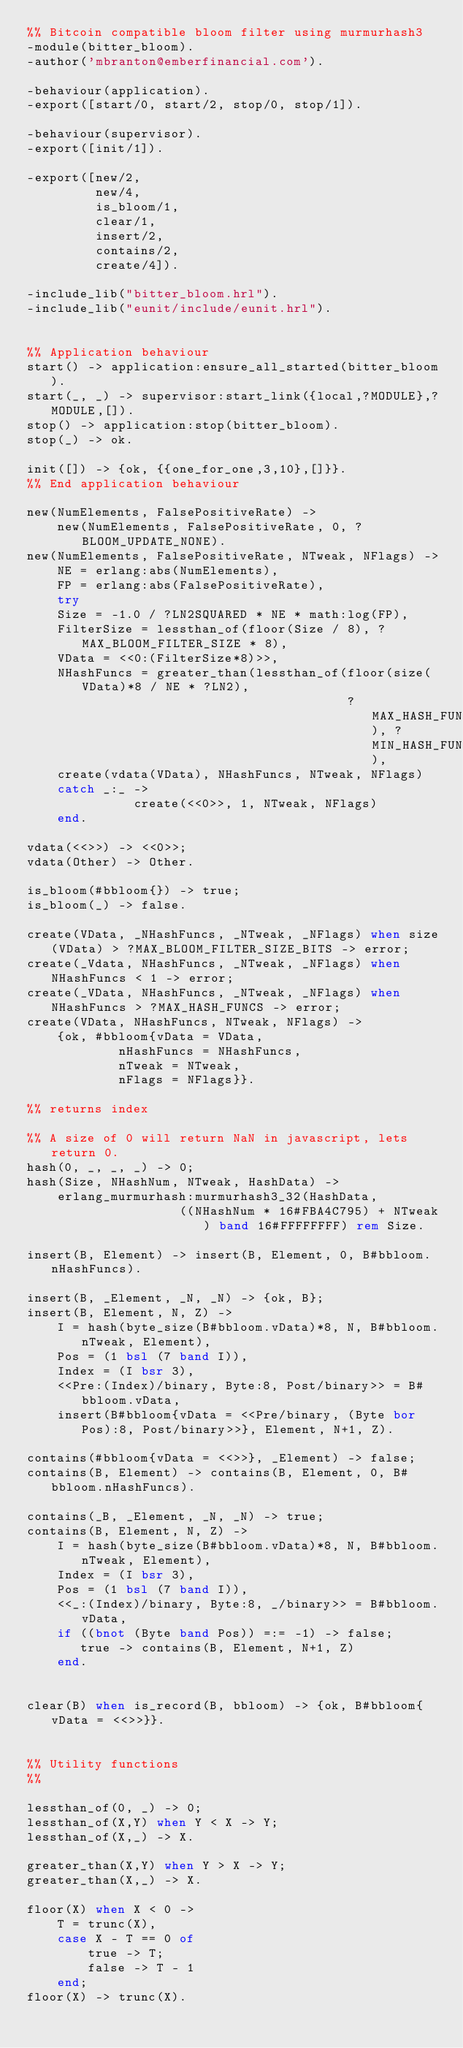<code> <loc_0><loc_0><loc_500><loc_500><_Erlang_>%% Bitcoin compatible bloom filter using murmurhash3
-module(bitter_bloom).
-author('mbranton@emberfinancial.com').

-behaviour(application).
-export([start/0, start/2, stop/0, stop/1]).

-behaviour(supervisor).
-export([init/1]).

-export([new/2,
		 new/4,
		 is_bloom/1,
		 clear/1,
		 insert/2,
		 contains/2,
		 create/4]).

-include_lib("bitter_bloom.hrl").
-include_lib("eunit/include/eunit.hrl").


%% Application behaviour
start() -> application:ensure_all_started(bitter_bloom).
start(_, _) -> supervisor:start_link({local,?MODULE},?MODULE,[]).
stop() -> application:stop(bitter_bloom).
stop(_) -> ok.

init([]) -> {ok, {{one_for_one,3,10},[]}}.
%% End application behaviour

new(NumElements, FalsePositiveRate) ->
	new(NumElements, FalsePositiveRate, 0, ?BLOOM_UPDATE_NONE).
new(NumElements, FalsePositiveRate, NTweak, NFlags) ->
	NE = erlang:abs(NumElements),
	FP = erlang:abs(FalsePositiveRate),
	try
	Size = -1.0 / ?LN2SQUARED * NE * math:log(FP),
	FilterSize = lessthan_of(floor(Size / 8), ?MAX_BLOOM_FILTER_SIZE * 8),
	VData = <<0:(FilterSize*8)>>,
	NHashFuncs = greater_than(lessthan_of(floor(size(VData)*8 / NE * ?LN2),
										  ?MAX_HASH_FUNCS), ?MIN_HASH_FUNCS),
	create(vdata(VData), NHashFuncs, NTweak, NFlags)
	catch _:_ ->
			  create(<<0>>, 1, NTweak, NFlags)
	end.

vdata(<<>>) -> <<0>>;
vdata(Other) -> Other.

is_bloom(#bbloom{}) -> true;
is_bloom(_) -> false.

create(VData, _NHashFuncs, _NTweak, _NFlags) when size(VData) > ?MAX_BLOOM_FILTER_SIZE_BITS -> error;
create(_Vdata, NHashFuncs, _NTweak, _NFlags) when NHashFuncs < 1 -> error;
create(_VData, NHashFuncs, _NTweak, _NFlags) when NHashFuncs > ?MAX_HASH_FUNCS -> error;
create(VData, NHashFuncs, NTweak, NFlags) ->
	{ok, #bbloom{vData = VData,
		    nHashFuncs = NHashFuncs,
		    nTweak = NTweak,
		    nFlags = NFlags}}.

%% returns index

%% A size of 0 will return NaN in javascript, lets return 0.
hash(0, _, _, _) -> 0;
hash(Size, NHashNum, NTweak, HashData) ->
	erlang_murmurhash:murmurhash3_32(HashData,
					((NHashNum * 16#FBA4C795) + NTweak) band 16#FFFFFFFF) rem Size.

insert(B, Element) -> insert(B, Element, 0, B#bbloom.nHashFuncs).

insert(B, _Element, _N, _N) -> {ok, B};
insert(B, Element, N, Z) ->
	I = hash(byte_size(B#bbloom.vData)*8, N, B#bbloom.nTweak, Element),
	Pos = (1 bsl (7 band I)),
	Index = (I bsr 3),
	<<Pre:(Index)/binary, Byte:8, Post/binary>> = B#bbloom.vData,
	insert(B#bbloom{vData = <<Pre/binary, (Byte bor Pos):8, Post/binary>>}, Element, N+1, Z).

contains(#bbloom{vData = <<>>}, _Element) -> false;
contains(B, Element) -> contains(B, Element, 0, B#bbloom.nHashFuncs).

contains(_B, _Element, _N, _N) -> true;
contains(B, Element, N, Z) ->
	I = hash(byte_size(B#bbloom.vData)*8, N, B#bbloom.nTweak, Element),
	Index = (I bsr 3),
	Pos = (1 bsl (7 band I)),
	<<_:(Index)/binary, Byte:8, _/binary>> = B#bbloom.vData,
	if ((bnot (Byte band Pos)) =:= -1) -> false;
	   true -> contains(B, Element, N+1, Z)
	end.


clear(B) when is_record(B, bbloom) -> {ok, B#bbloom{vData = <<>>}}.


%% Utility functions
%%

lessthan_of(0, _) -> 0;
lessthan_of(X,Y) when Y < X -> Y;
lessthan_of(X,_) -> X.

greater_than(X,Y) when Y > X -> Y;
greater_than(X,_) -> X.

floor(X) when X < 0 ->
    T = trunc(X),
    case X - T == 0 of
        true -> T;
        false -> T - 1
    end;
floor(X) -> trunc(X).
</code> 